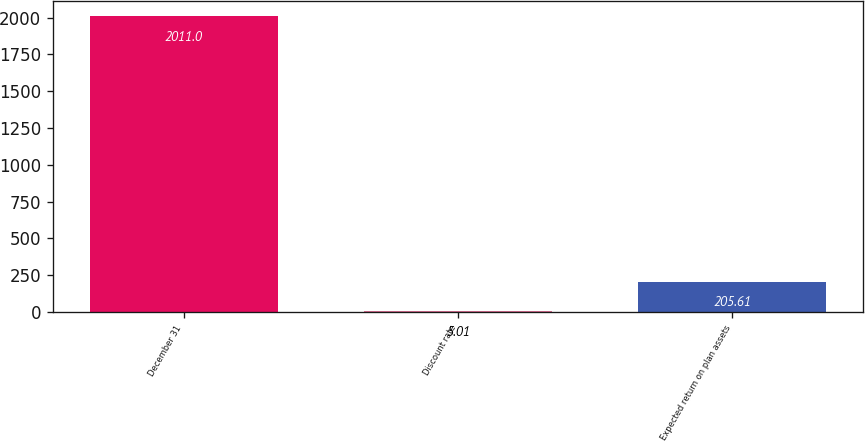Convert chart to OTSL. <chart><loc_0><loc_0><loc_500><loc_500><bar_chart><fcel>December 31<fcel>Discount rate<fcel>Expected return on plan assets<nl><fcel>2011<fcel>5.01<fcel>205.61<nl></chart> 